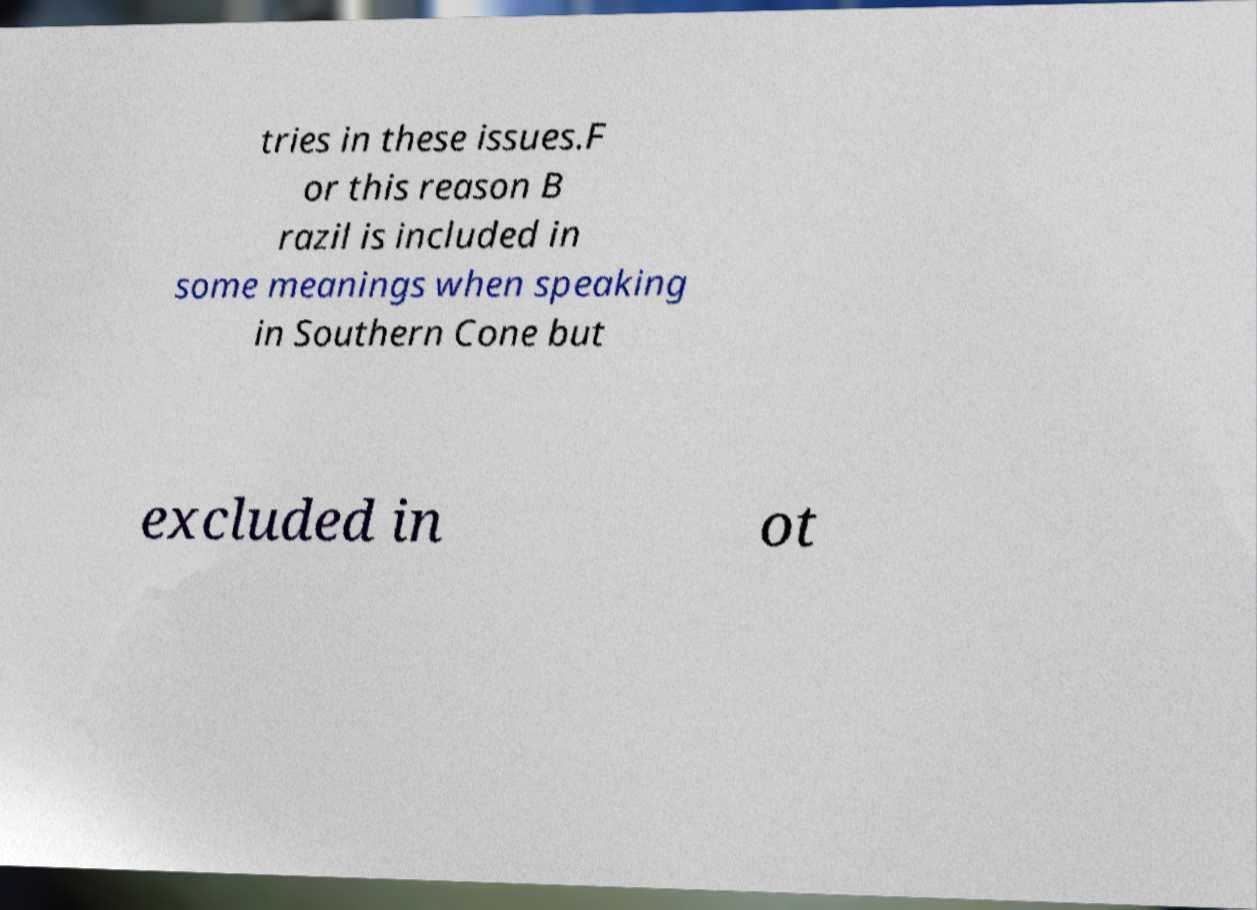Could you assist in decoding the text presented in this image and type it out clearly? tries in these issues.F or this reason B razil is included in some meanings when speaking in Southern Cone but excluded in ot 